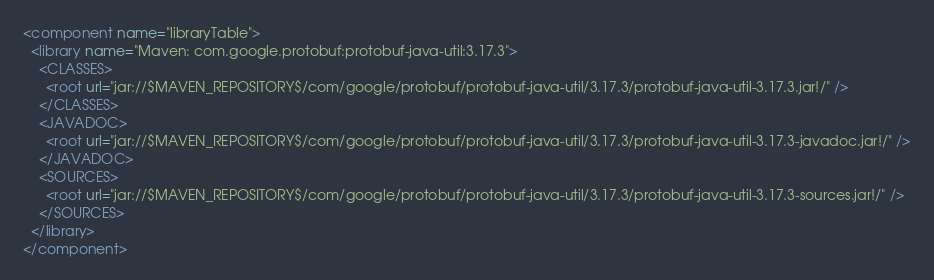<code> <loc_0><loc_0><loc_500><loc_500><_XML_><component name="libraryTable">
  <library name="Maven: com.google.protobuf:protobuf-java-util:3.17.3">
    <CLASSES>
      <root url="jar://$MAVEN_REPOSITORY$/com/google/protobuf/protobuf-java-util/3.17.3/protobuf-java-util-3.17.3.jar!/" />
    </CLASSES>
    <JAVADOC>
      <root url="jar://$MAVEN_REPOSITORY$/com/google/protobuf/protobuf-java-util/3.17.3/protobuf-java-util-3.17.3-javadoc.jar!/" />
    </JAVADOC>
    <SOURCES>
      <root url="jar://$MAVEN_REPOSITORY$/com/google/protobuf/protobuf-java-util/3.17.3/protobuf-java-util-3.17.3-sources.jar!/" />
    </SOURCES>
  </library>
</component></code> 